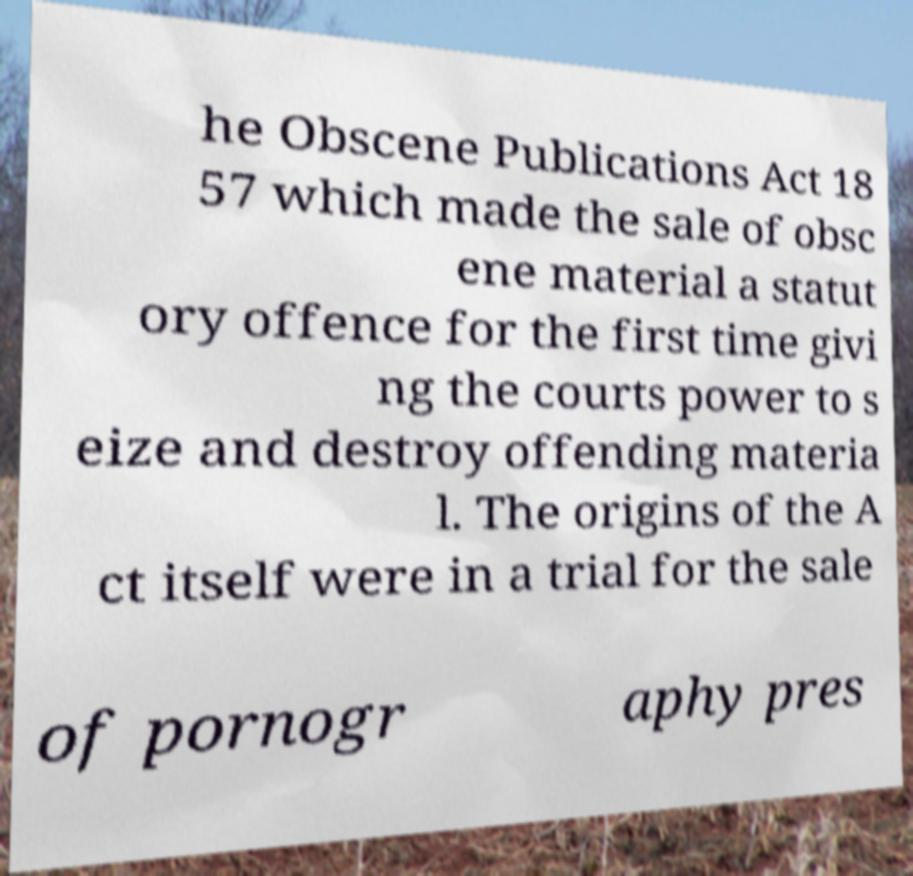For documentation purposes, I need the text within this image transcribed. Could you provide that? he Obscene Publications Act 18 57 which made the sale of obsc ene material a statut ory offence for the first time givi ng the courts power to s eize and destroy offending materia l. The origins of the A ct itself were in a trial for the sale of pornogr aphy pres 